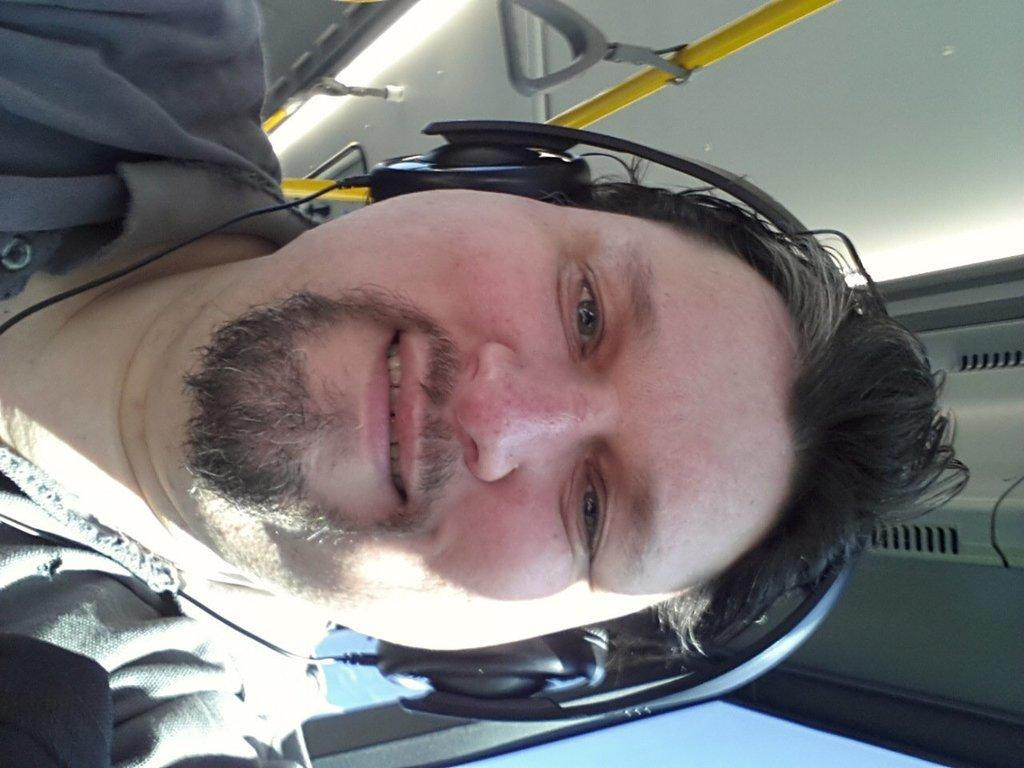Who is present in the image? There is a person in the image. What is the person wearing on their upper body? The person is wearing a green shirt. What is the person wearing on their head? The person is wearing a headset. What can be seen in the background of the image? There is a yellow pole in the image. What reason does the person give for coughing in the image? There is no coughing or reason mentioned in the image; it only shows a person wearing a green shirt and a headset, with a yellow pole in the background. 